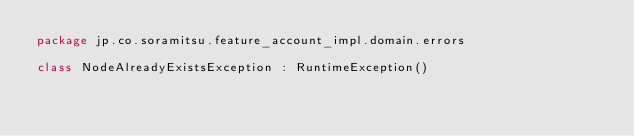Convert code to text. <code><loc_0><loc_0><loc_500><loc_500><_Kotlin_>package jp.co.soramitsu.feature_account_impl.domain.errors

class NodeAlreadyExistsException : RuntimeException()
</code> 